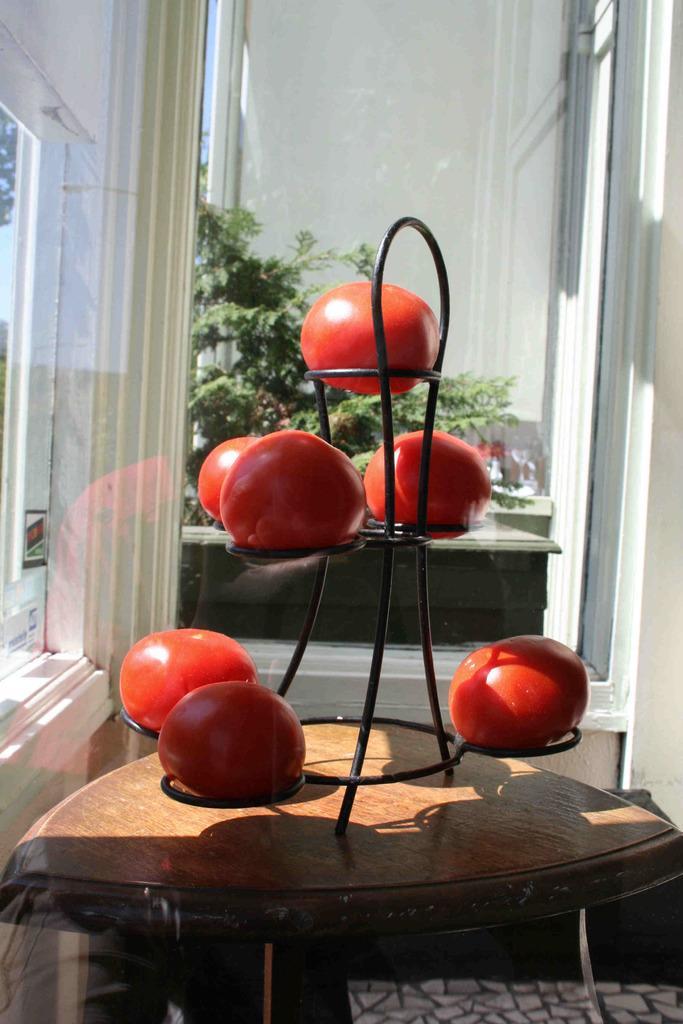Please provide a concise description of this image. In the picture we can find a house inside it we can find a table on that we find a stand of tomatoes. In the background we can find some plants. 